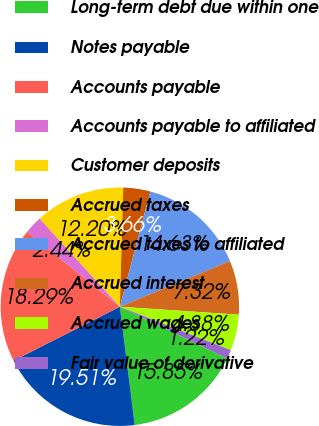Convert chart. <chart><loc_0><loc_0><loc_500><loc_500><pie_chart><fcel>Long-term debt due within one<fcel>Notes payable<fcel>Accounts payable<fcel>Accounts payable to affiliated<fcel>Customer deposits<fcel>Accrued taxes<fcel>Accrued taxes to affiliated<fcel>Accrued interest<fcel>Accrued wages<fcel>Fair value of derivative<nl><fcel>15.85%<fcel>19.51%<fcel>18.29%<fcel>2.44%<fcel>12.2%<fcel>3.66%<fcel>14.63%<fcel>7.32%<fcel>4.88%<fcel>1.22%<nl></chart> 